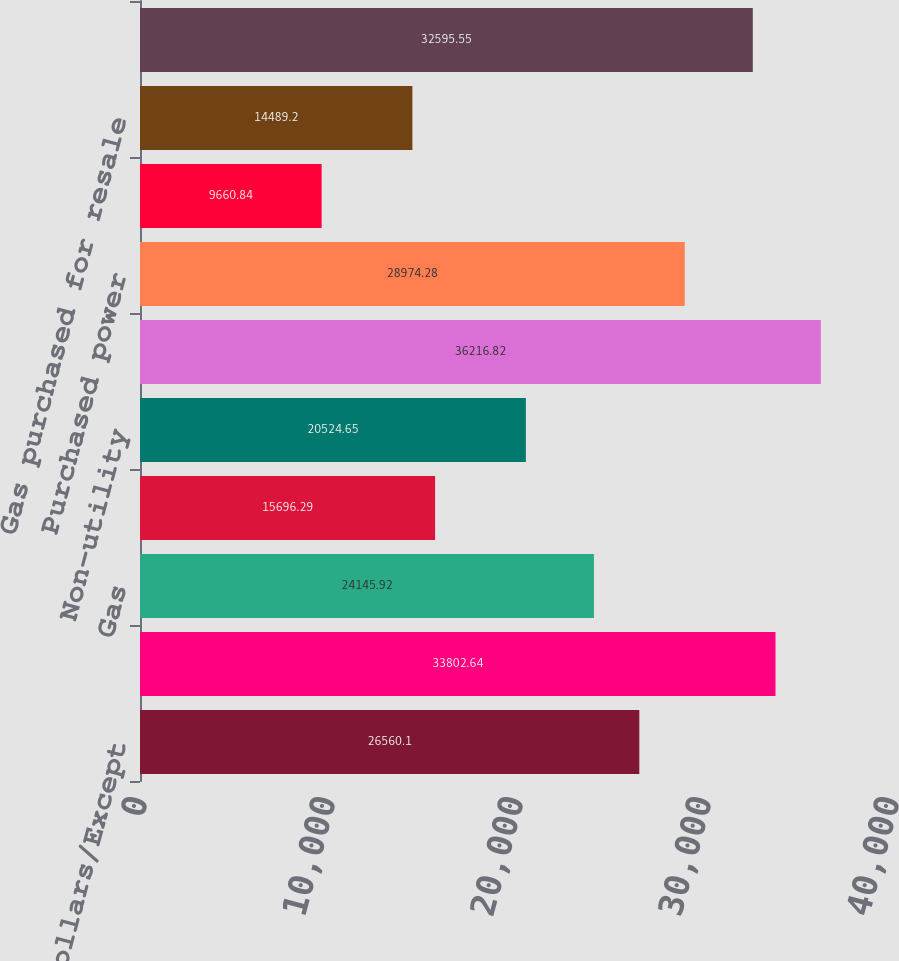Convert chart. <chart><loc_0><loc_0><loc_500><loc_500><bar_chart><fcel>(Millions of Dollars/Except<fcel>Electric<fcel>Gas<fcel>Steam<fcel>Non-utility<fcel>TOTAL OPERATING REVENUES<fcel>Purchased power<fcel>Fuel<fcel>Gas purchased for resale<fcel>Other operations and<nl><fcel>26560.1<fcel>33802.6<fcel>24145.9<fcel>15696.3<fcel>20524.7<fcel>36216.8<fcel>28974.3<fcel>9660.84<fcel>14489.2<fcel>32595.5<nl></chart> 